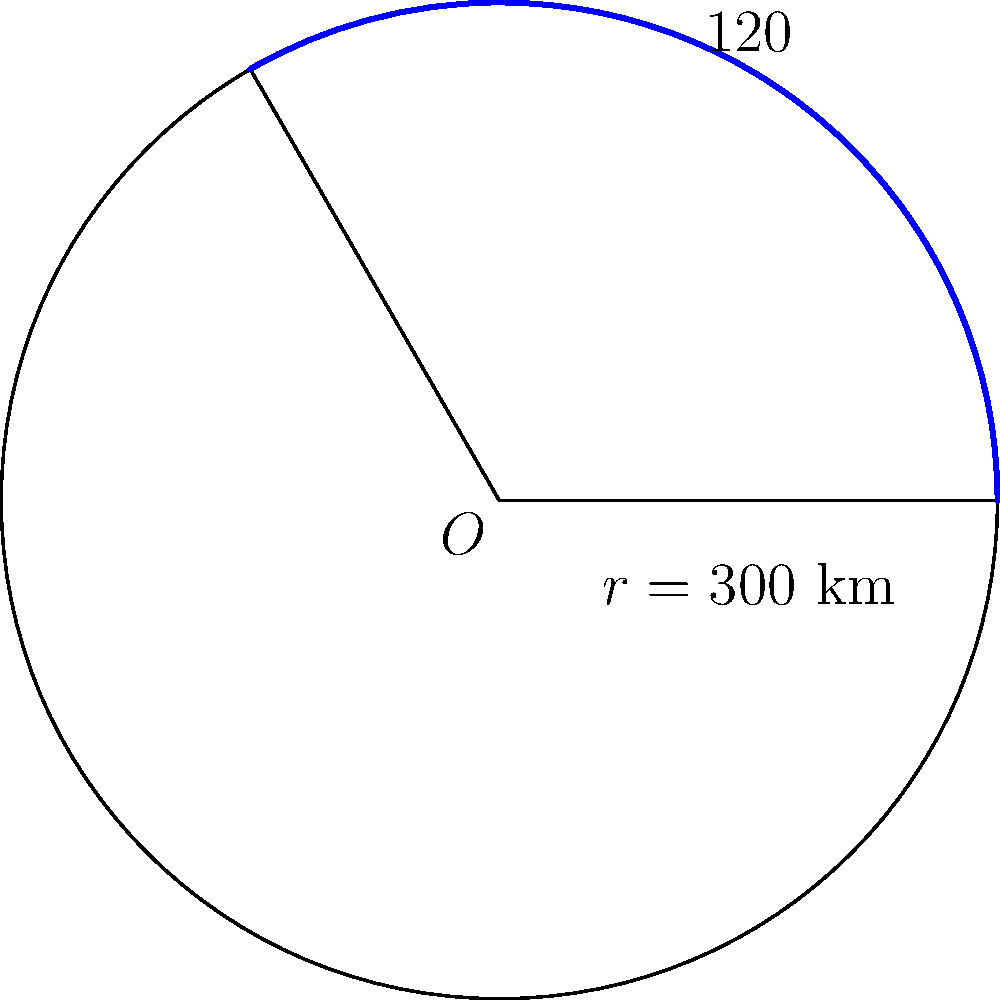A military radar system covers a circular sector with a central angle of 120° and a radius of 300 km. What is the area of the region covered by this radar system? Round your answer to the nearest whole number. To find the area of a circular sector, we can use the formula:

$$A = \frac{\theta}{360°} \cdot \pi r^2$$

Where:
$A$ is the area of the sector
$\theta$ is the central angle in degrees
$r$ is the radius of the circle

Given:
$\theta = 120°$
$r = 300$ km

Let's solve step by step:

1) Substitute the values into the formula:
   $$A = \frac{120°}{360°} \cdot \pi (300 \text{ km})^2$$

2) Simplify the fraction:
   $$A = \frac{1}{3} \cdot \pi (300 \text{ km})^2$$

3) Calculate $300^2$:
   $$A = \frac{1}{3} \cdot \pi \cdot 90,000 \text{ km}^2$$

4) Multiply:
   $$A = 30,000\pi \text{ km}^2$$

5) Calculate and round to the nearest whole number:
   $$A \approx 94,248 \text{ km}^2$$

Thus, the area covered by the radar system is approximately 94,248 square kilometers.
Answer: 94,248 km² 